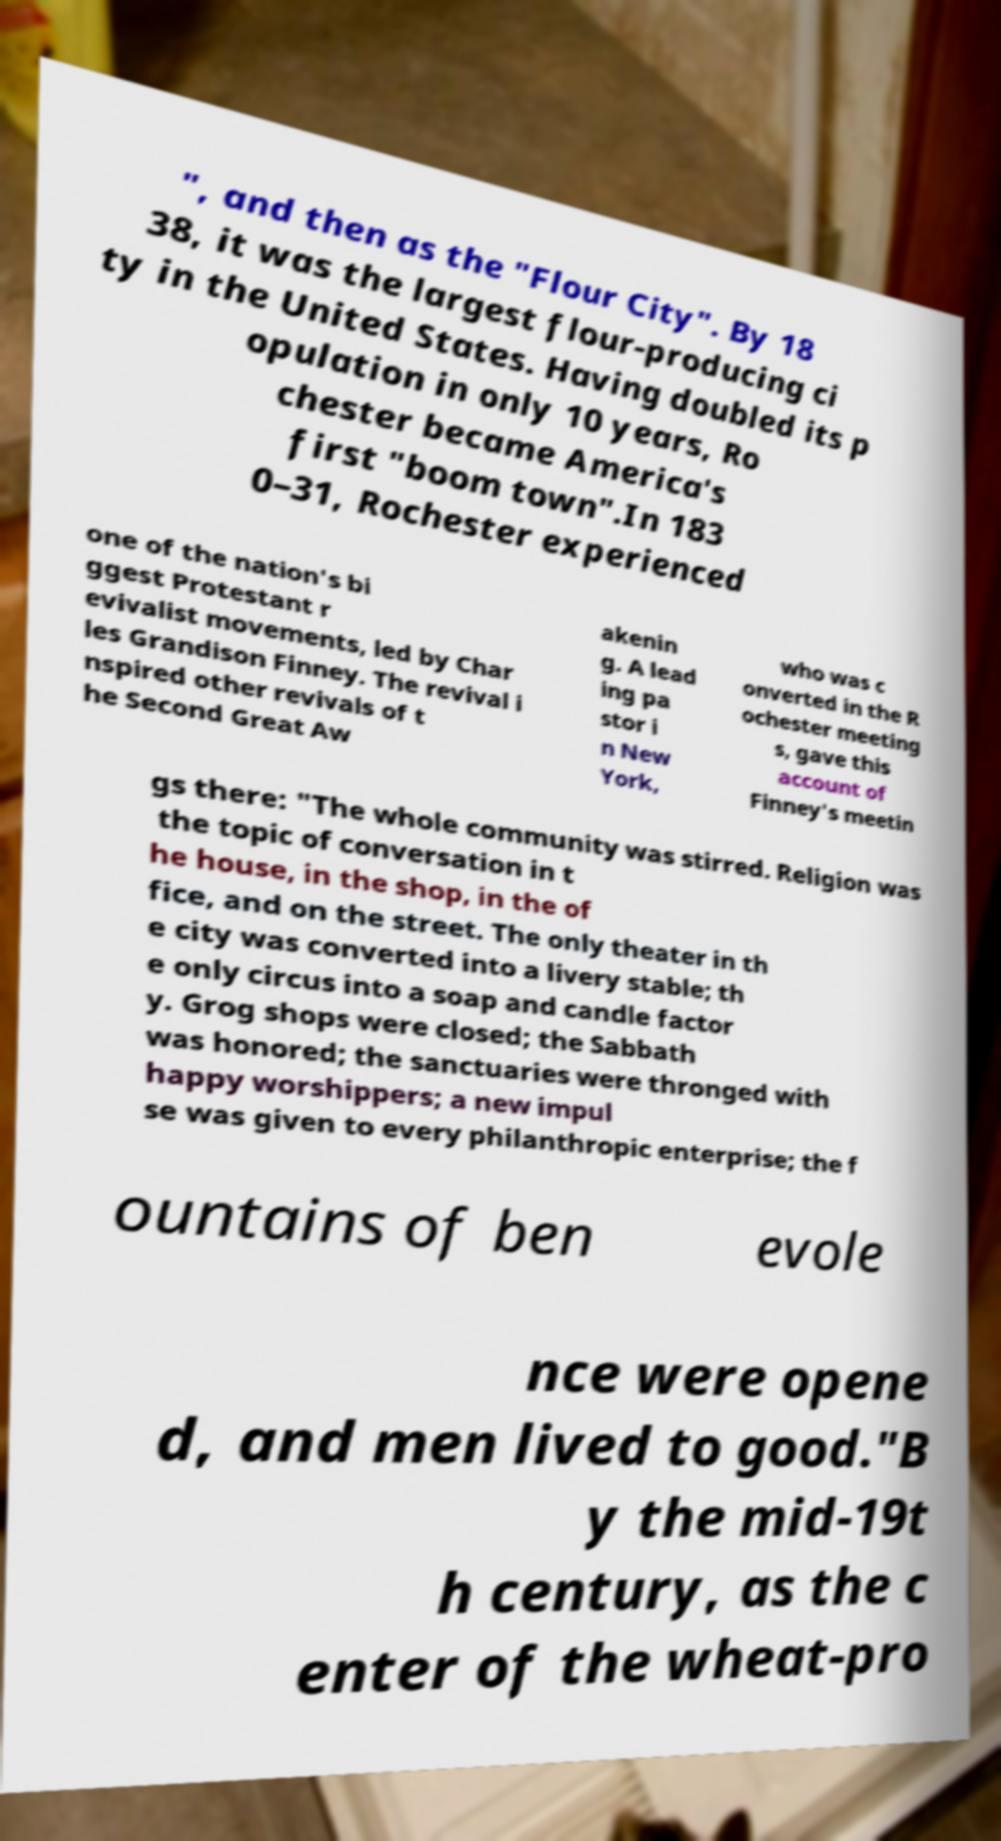Could you assist in decoding the text presented in this image and type it out clearly? ", and then as the "Flour City". By 18 38, it was the largest flour-producing ci ty in the United States. Having doubled its p opulation in only 10 years, Ro chester became America's first "boom town".In 183 0–31, Rochester experienced one of the nation's bi ggest Protestant r evivalist movements, led by Char les Grandison Finney. The revival i nspired other revivals of t he Second Great Aw akenin g. A lead ing pa stor i n New York, who was c onverted in the R ochester meeting s, gave this account of Finney's meetin gs there: "The whole community was stirred. Religion was the topic of conversation in t he house, in the shop, in the of fice, and on the street. The only theater in th e city was converted into a livery stable; th e only circus into a soap and candle factor y. Grog shops were closed; the Sabbath was honored; the sanctuaries were thronged with happy worshippers; a new impul se was given to every philanthropic enterprise; the f ountains of ben evole nce were opene d, and men lived to good."B y the mid-19t h century, as the c enter of the wheat-pro 